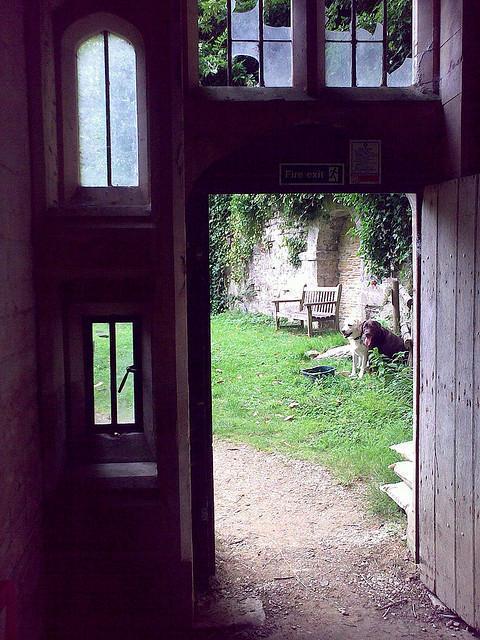How many dogs are there?
Give a very brief answer. 2. 